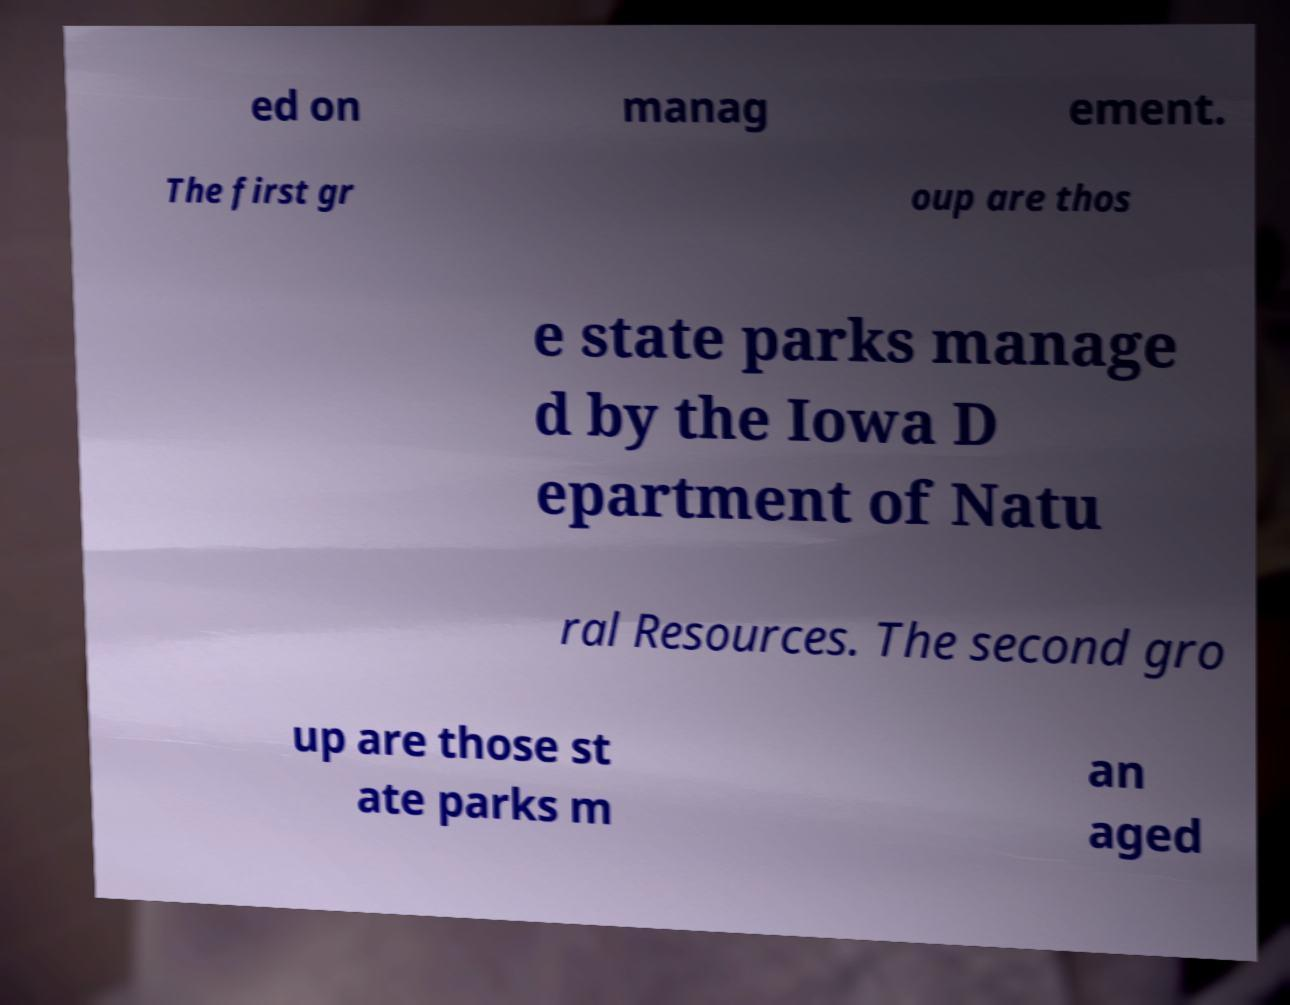Can you read and provide the text displayed in the image?This photo seems to have some interesting text. Can you extract and type it out for me? ed on manag ement. The first gr oup are thos e state parks manage d by the Iowa D epartment of Natu ral Resources. The second gro up are those st ate parks m an aged 